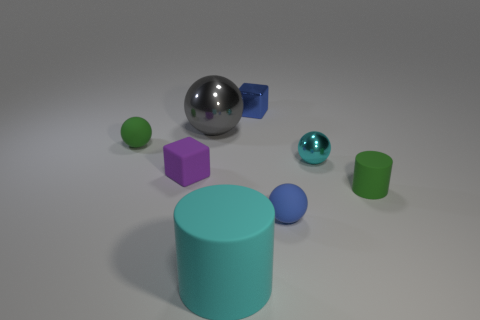Subtract all big gray spheres. How many spheres are left? 3 Subtract all blue spheres. How many spheres are left? 3 Add 2 tiny things. How many objects exist? 10 Subtract 2 cylinders. How many cylinders are left? 0 Subtract 0 brown spheres. How many objects are left? 8 Subtract all cylinders. How many objects are left? 6 Subtract all brown spheres. Subtract all brown blocks. How many spheres are left? 4 Subtract all cyan metallic things. Subtract all shiny blocks. How many objects are left? 6 Add 4 blocks. How many blocks are left? 6 Add 1 big gray metal blocks. How many big gray metal blocks exist? 1 